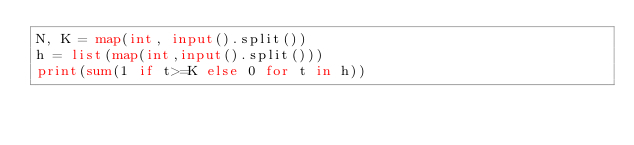<code> <loc_0><loc_0><loc_500><loc_500><_Python_>N, K = map(int, input().split())
h = list(map(int,input().split()))
print(sum(1 if t>=K else 0 for t in h))</code> 